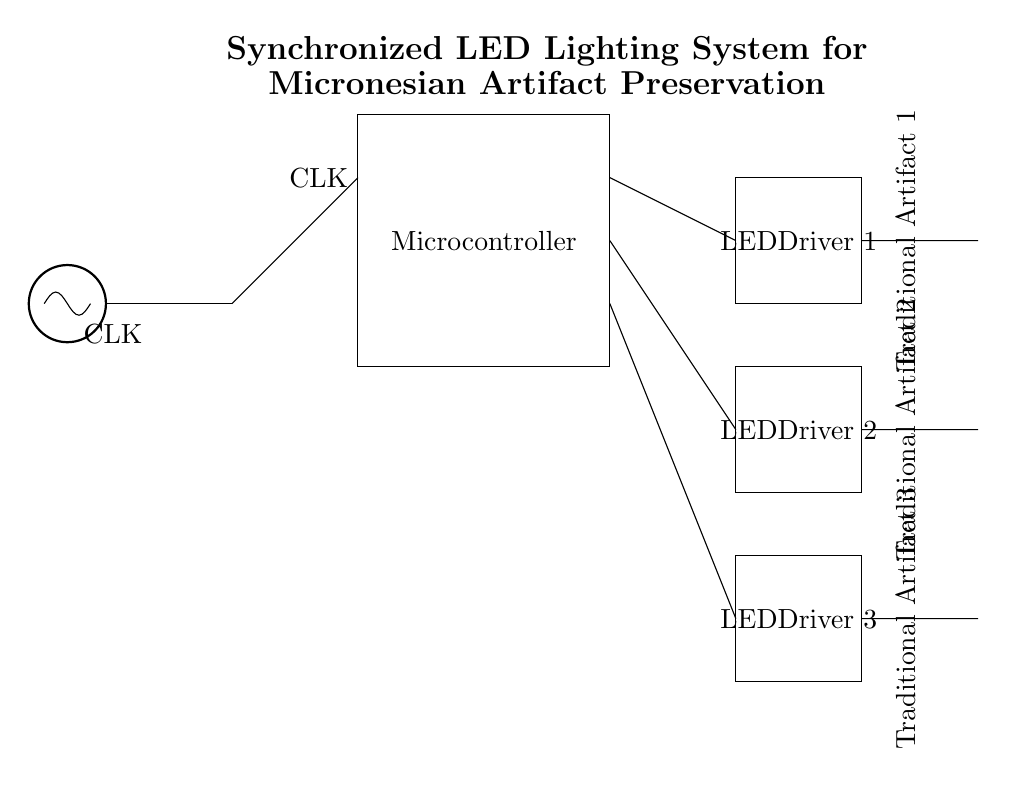What is the purpose of the microcontroller in this circuit? The microcontroller controls the LED drivers based on the clock signal it receives. It manages the timing and operation of the LEDs to ensure they are synchronized correctly for displaying the artifacts.
Answer: Control LEDs How many LED drivers are present in this circuit? There are three LED drivers visible in the circuit diagram, each dedicated to driving individual LEDs connected to traditional artifacts.
Answer: Three What is the role of the clock generator in this circuit? The clock generator provides a timing signal (CLK) that synchronizes the operations of the microcontroller and subsequently the LED drivers, ensuring a coordinated lighting effect.
Answer: Synchronization What type of connection is used between the microcontroller and the LED drivers? The connections between the microcontroller and the LED drivers are direct connections, without any intermediate components indicated, simplifying control of the LEDs.
Answer: Direct connections Which traditional artifact is labeled closest to the first LED? The first LED is labeled as corresponding to Traditional Artifact 1, which means it is the artifact that will be illuminated by the first LED driver in the circuit.
Answer: Traditional Artifact 1 What is the function of the LEDs in this circuit diagram? The LEDs are used to illuminate the displayed traditional artifacts to enhance their visibility and aesthetic appeal, showcasing the artifacts effectively.
Answer: Illuminate artifacts 